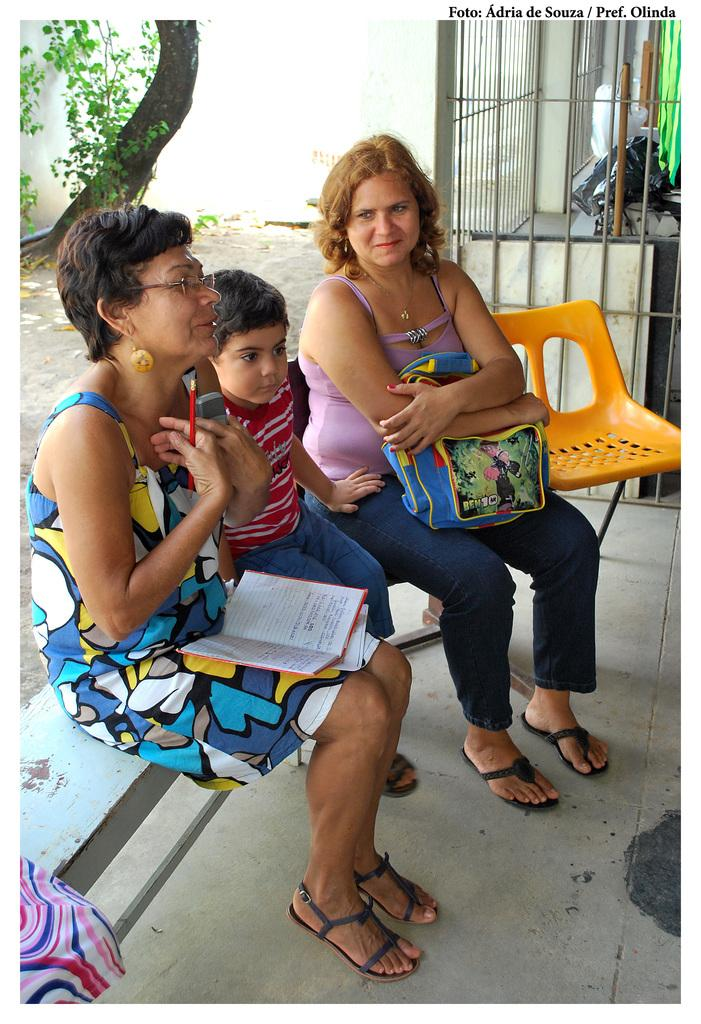How many people are in the image? There are three individuals in the image, two women and a child. What are the three individuals doing in the image? The three individuals are sitting on a bench. What is located beside the bench in the image? There is an orange chair beside the bench. What can be seen in the background of the image? There is a tree and a plant in the background of the image. What type of salt is being used by the flock of birds in the image? There are no birds or salt present in the image. What is the destination of the voyage depicted in the image? There is no voyage depicted in the image; it features three individuals sitting on a bench. 